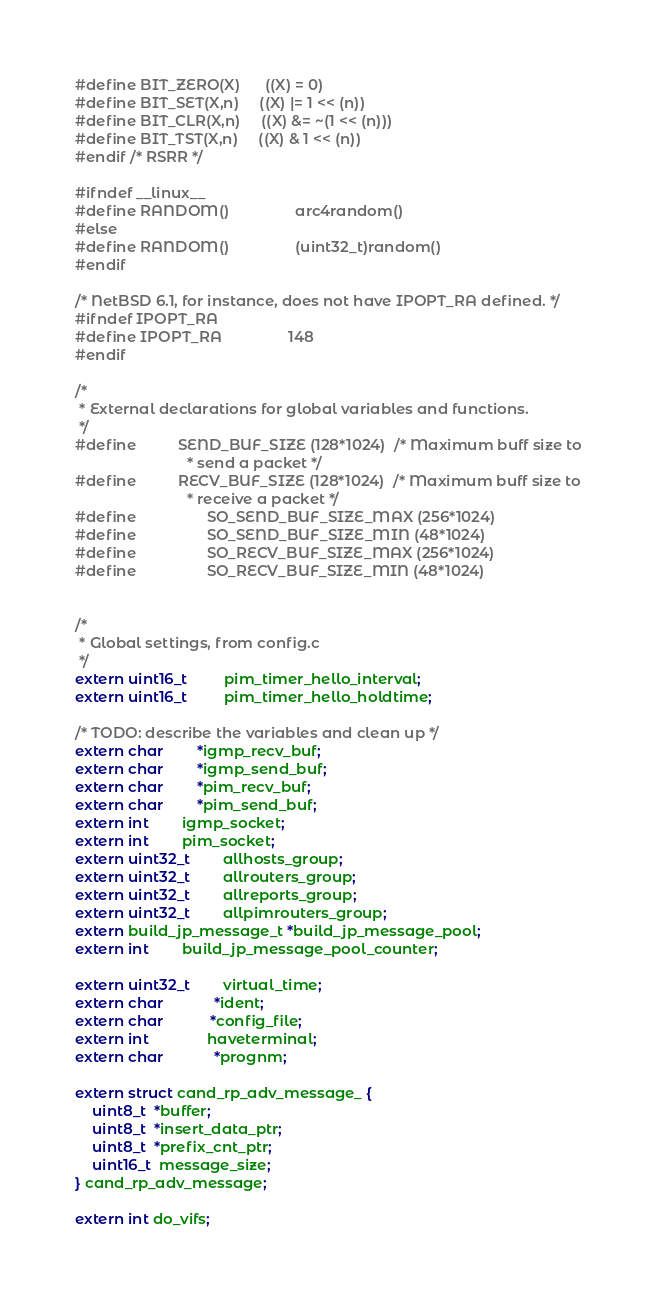<code> <loc_0><loc_0><loc_500><loc_500><_C_>#define BIT_ZERO(X)		((X) = 0)
#define BIT_SET(X,n)		((X) |= 1 << (n))
#define BIT_CLR(X,n)		((X) &= ~(1 << (n)))
#define BIT_TST(X,n)		((X) & 1 << (n))
#endif /* RSRR */

#ifndef __linux__
#define RANDOM()                arc4random()
#else
#define RANDOM()                (uint32_t)random()
#endif

/* NetBSD 6.1, for instance, does not have IPOPT_RA defined. */
#ifndef IPOPT_RA
#define IPOPT_RA                148
#endif

/*
 * External declarations for global variables and functions.
 */
#define			SEND_BUF_SIZE (128*1024)  /* Maximum buff size to
						   * send a packet */
#define			RECV_BUF_SIZE (128*1024)  /* Maximum buff size to
						   * receive a packet */
#define                 SO_SEND_BUF_SIZE_MAX (256*1024)
#define                 SO_SEND_BUF_SIZE_MIN (48*1024)
#define                 SO_RECV_BUF_SIZE_MAX (256*1024)
#define                 SO_RECV_BUF_SIZE_MIN (48*1024)


/*
 * Global settings, from config.c
 */
extern uint16_t         pim_timer_hello_interval;
extern uint16_t         pim_timer_hello_holdtime;

/* TODO: describe the variables and clean up */
extern char		*igmp_recv_buf;
extern char		*igmp_send_buf;
extern char		*pim_recv_buf;
extern char		*pim_send_buf;
extern int		igmp_socket;
extern int		pim_socket;
extern uint32_t		allhosts_group;
extern uint32_t		allrouters_group;
extern uint32_t		allreports_group;
extern uint32_t		allpimrouters_group;
extern build_jp_message_t *build_jp_message_pool;
extern int		build_jp_message_pool_counter;

extern uint32_t		virtual_time;
extern char            *ident;
extern char	       *config_file;
extern int              haveterminal;
extern char            *prognm;

extern struct cand_rp_adv_message_ {
    uint8_t  *buffer;
    uint8_t  *insert_data_ptr;
    uint8_t  *prefix_cnt_ptr;
    uint16_t  message_size;
} cand_rp_adv_message;

extern int do_vifs;</code> 